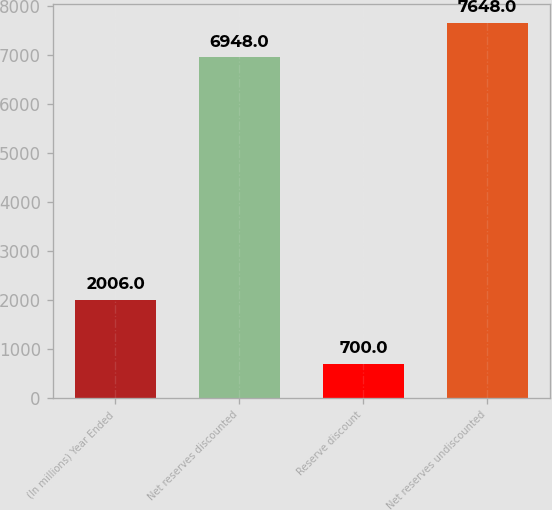Convert chart. <chart><loc_0><loc_0><loc_500><loc_500><bar_chart><fcel>(In millions) Year Ended<fcel>Net reserves discounted<fcel>Reserve discount<fcel>Net reserves undiscounted<nl><fcel>2006<fcel>6948<fcel>700<fcel>7648<nl></chart> 